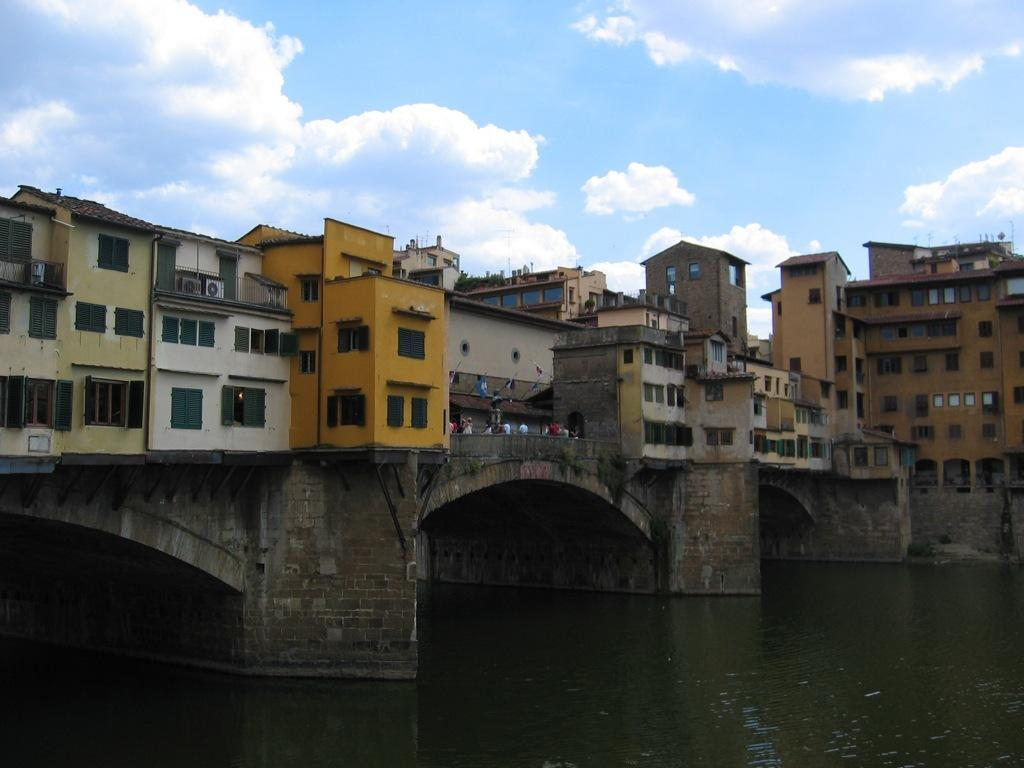What is the main feature of the image? There is water in the image. What structure can be seen crossing the water? There is a bridge in the image. What is located on the bridge? There are buildings on the bridge. Are there any people present in the image? Yes, there are people standing on the bridge. What can be seen in the background of the image? The sky is visible in the background of the image. What type of list can be seen hanging from the bridge in the image? There is no list present in the image; it features a bridge with buildings and people. Can you tell me how many birds are sitting on the buildings in the image? There are no birds present in the image; it only features a bridge, water, buildings, and people. 